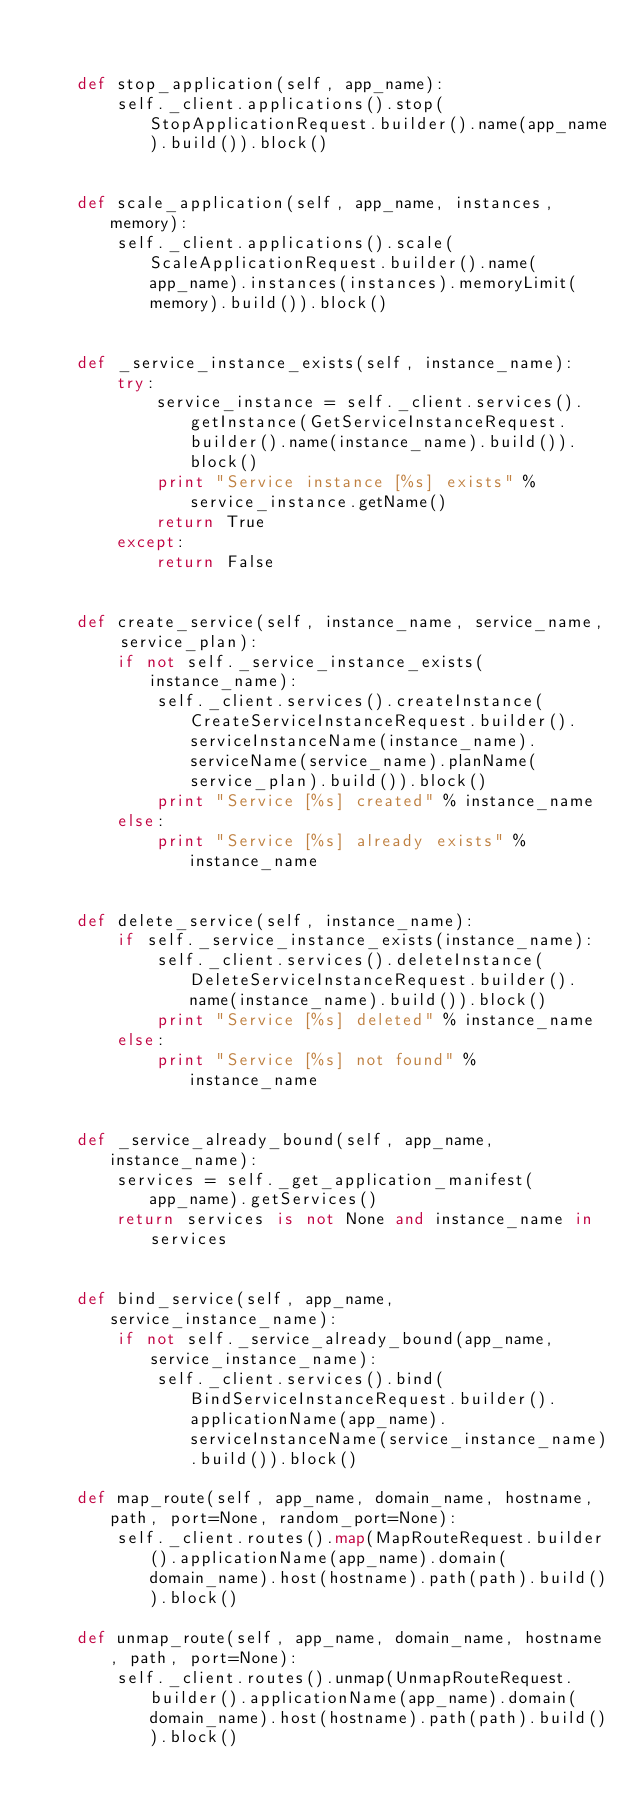Convert code to text. <code><loc_0><loc_0><loc_500><loc_500><_Python_>

    def stop_application(self, app_name):
        self._client.applications().stop(StopApplicationRequest.builder().name(app_name).build()).block()


    def scale_application(self, app_name, instances, memory):
        self._client.applications().scale(ScaleApplicationRequest.builder().name(app_name).instances(instances).memoryLimit(memory).build()).block()


    def _service_instance_exists(self, instance_name):
        try:
            service_instance = self._client.services().getInstance(GetServiceInstanceRequest.builder().name(instance_name).build()).block()
            print "Service instance [%s] exists" % service_instance.getName()
            return True
        except:
            return False


    def create_service(self, instance_name, service_name, service_plan):
        if not self._service_instance_exists(instance_name):
            self._client.services().createInstance(CreateServiceInstanceRequest.builder().serviceInstanceName(instance_name).serviceName(service_name).planName(service_plan).build()).block()
            print "Service [%s] created" % instance_name
        else:
            print "Service [%s] already exists" % instance_name


    def delete_service(self, instance_name):
        if self._service_instance_exists(instance_name):
            self._client.services().deleteInstance(DeleteServiceInstanceRequest.builder().name(instance_name).build()).block()
            print "Service [%s] deleted" % instance_name
        else:
            print "Service [%s] not found" % instance_name


    def _service_already_bound(self, app_name, instance_name):
        services = self._get_application_manifest(app_name).getServices()
        return services is not None and instance_name in services


    def bind_service(self, app_name, service_instance_name):
        if not self._service_already_bound(app_name, service_instance_name):
            self._client.services().bind(BindServiceInstanceRequest.builder().applicationName(app_name).serviceInstanceName(service_instance_name).build()).block()

    def map_route(self, app_name, domain_name, hostname, path, port=None, random_port=None):
        self._client.routes().map(MapRouteRequest.builder().applicationName(app_name).domain(domain_name).host(hostname).path(path).build()).block()

    def unmap_route(self, app_name, domain_name, hostname, path, port=None):
        self._client.routes().unmap(UnmapRouteRequest.builder().applicationName(app_name).domain(domain_name).host(hostname).path(path).build()).block()
</code> 